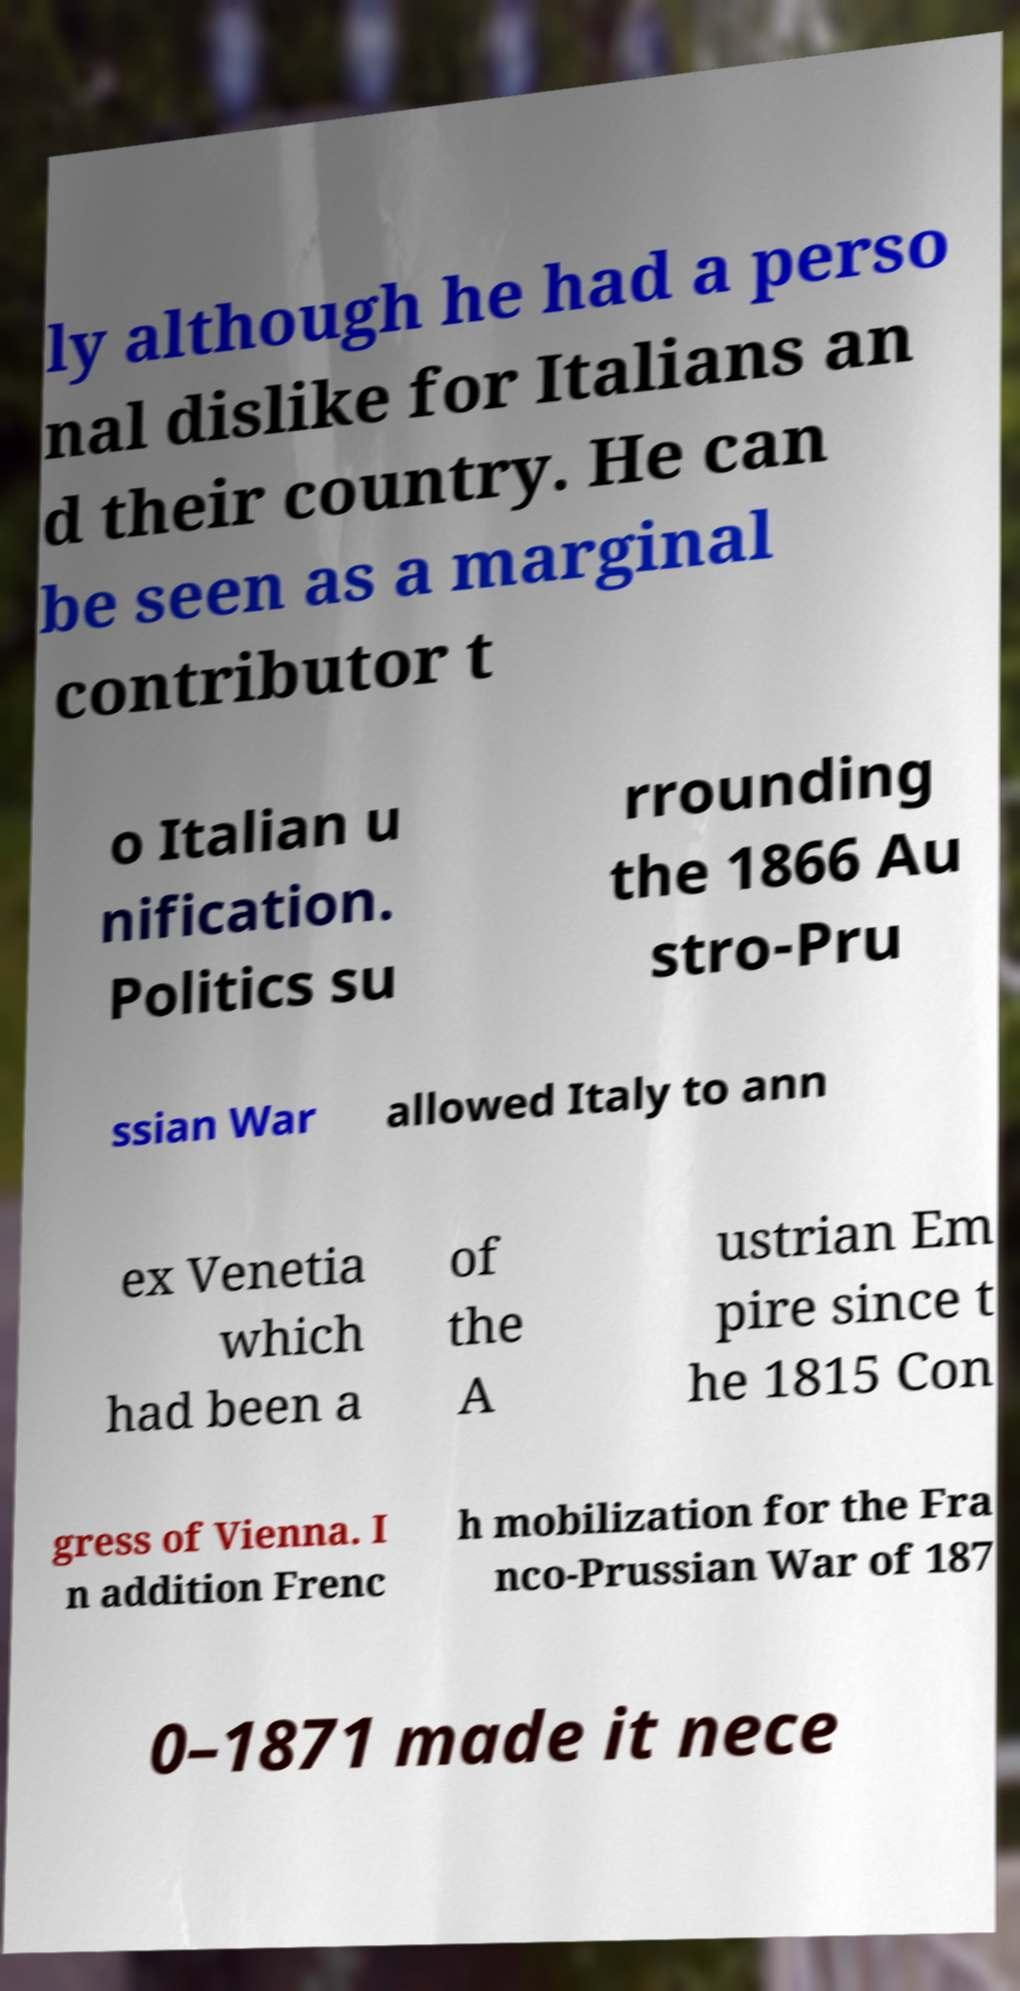Please identify and transcribe the text found in this image. ly although he had a perso nal dislike for Italians an d their country. He can be seen as a marginal contributor t o Italian u nification. Politics su rrounding the 1866 Au stro-Pru ssian War allowed Italy to ann ex Venetia which had been a of the A ustrian Em pire since t he 1815 Con gress of Vienna. I n addition Frenc h mobilization for the Fra nco-Prussian War of 187 0–1871 made it nece 